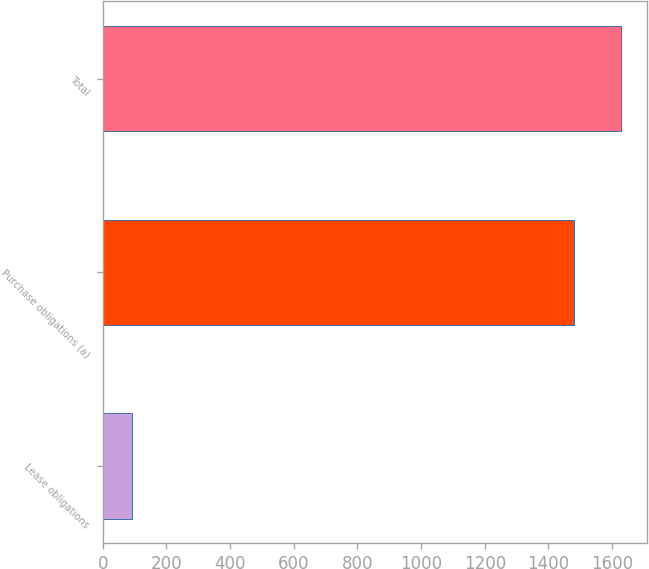<chart> <loc_0><loc_0><loc_500><loc_500><bar_chart><fcel>Lease obligations<fcel>Purchase obligations (a)<fcel>Total<nl><fcel>92<fcel>1480<fcel>1628<nl></chart> 